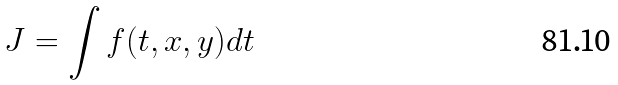<formula> <loc_0><loc_0><loc_500><loc_500>J = \int f ( t , x , y ) d t</formula> 